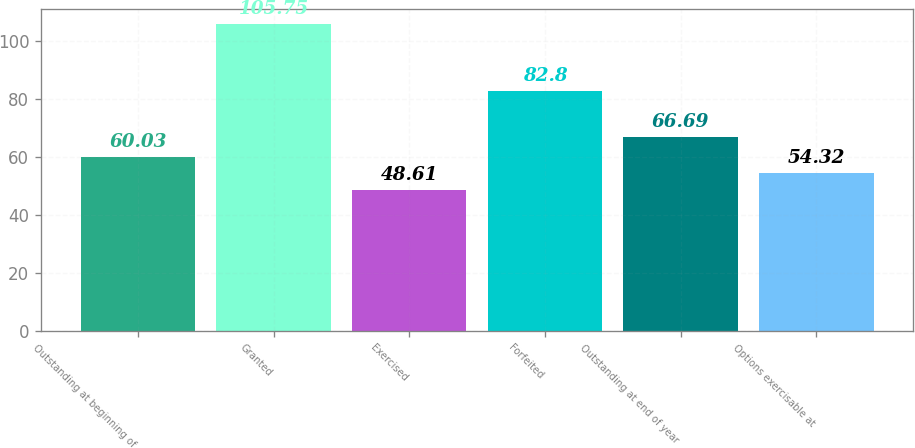Convert chart to OTSL. <chart><loc_0><loc_0><loc_500><loc_500><bar_chart><fcel>Outstanding at beginning of<fcel>Granted<fcel>Exercised<fcel>Forfeited<fcel>Outstanding at end of year<fcel>Options exercisable at<nl><fcel>60.03<fcel>105.75<fcel>48.61<fcel>82.8<fcel>66.69<fcel>54.32<nl></chart> 